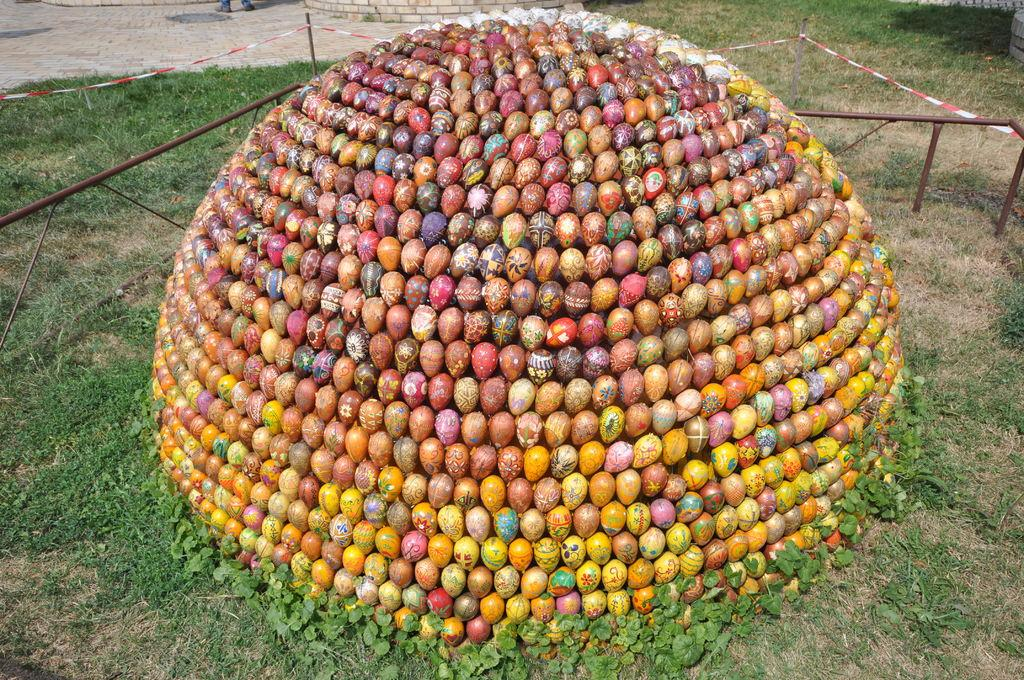What is the arrangement of the stones in the image? The stones are arranged in a circular manner on the grass. Where are the stones located in relation to the ground? The stones are on the surface. What can be seen behind the stones in the image? There is a path of a ground behind the stones. What type of wood can be seen in the image? There is no wood present in the image; it features stones arranged in a circular manner on the grass. What riddle is solved by the stones in the image? The image does not depict a riddle being solved; it simply shows stones arranged in a circular manner on the grass. 